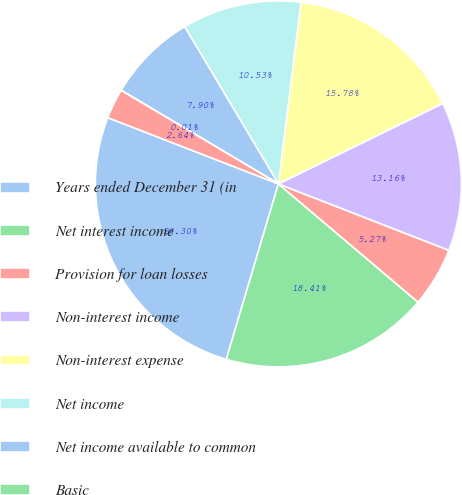Convert chart. <chart><loc_0><loc_0><loc_500><loc_500><pie_chart><fcel>Years ended December 31 (in<fcel>Net interest income<fcel>Provision for loan losses<fcel>Non-interest income<fcel>Non-interest expense<fcel>Net income<fcel>Net income available to common<fcel>Basic<fcel>Diluted<nl><fcel>26.3%<fcel>18.41%<fcel>5.27%<fcel>13.16%<fcel>15.78%<fcel>10.53%<fcel>7.9%<fcel>0.01%<fcel>2.64%<nl></chart> 